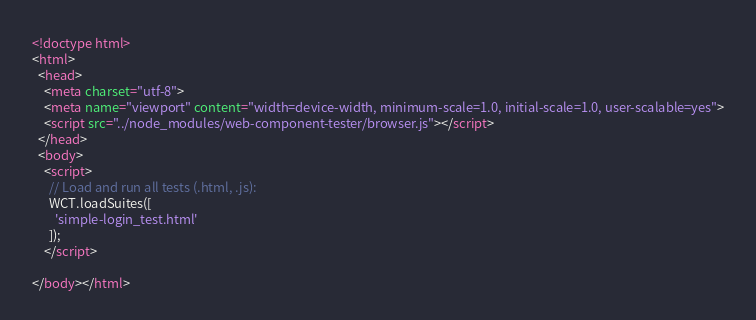<code> <loc_0><loc_0><loc_500><loc_500><_HTML_><!doctype html>
<html>
  <head>
    <meta charset="utf-8">
    <meta name="viewport" content="width=device-width, minimum-scale=1.0, initial-scale=1.0, user-scalable=yes">
    <script src="../node_modules/web-component-tester/browser.js"></script>
  </head>
  <body>
    <script>
      // Load and run all tests (.html, .js):
      WCT.loadSuites([
        'simple-login_test.html'
      ]);
    </script>

</body></html>
</code> 